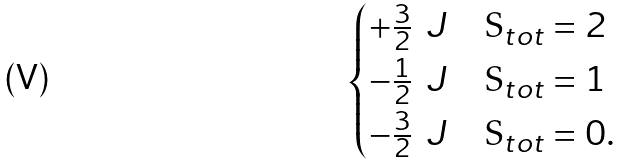Convert formula to latex. <formula><loc_0><loc_0><loc_500><loc_500>\begin{cases} + \frac { 3 } { 2 } \, \ J & \text {S$_{tot} = 2$} \\ - \frac { 1 } { 2 } \, \ J & \text {S$_{tot} = 1$} \\ - \frac { 3 } { 2 } \, \ J & \text {S$_{tot} = 0$.} \end{cases}</formula> 